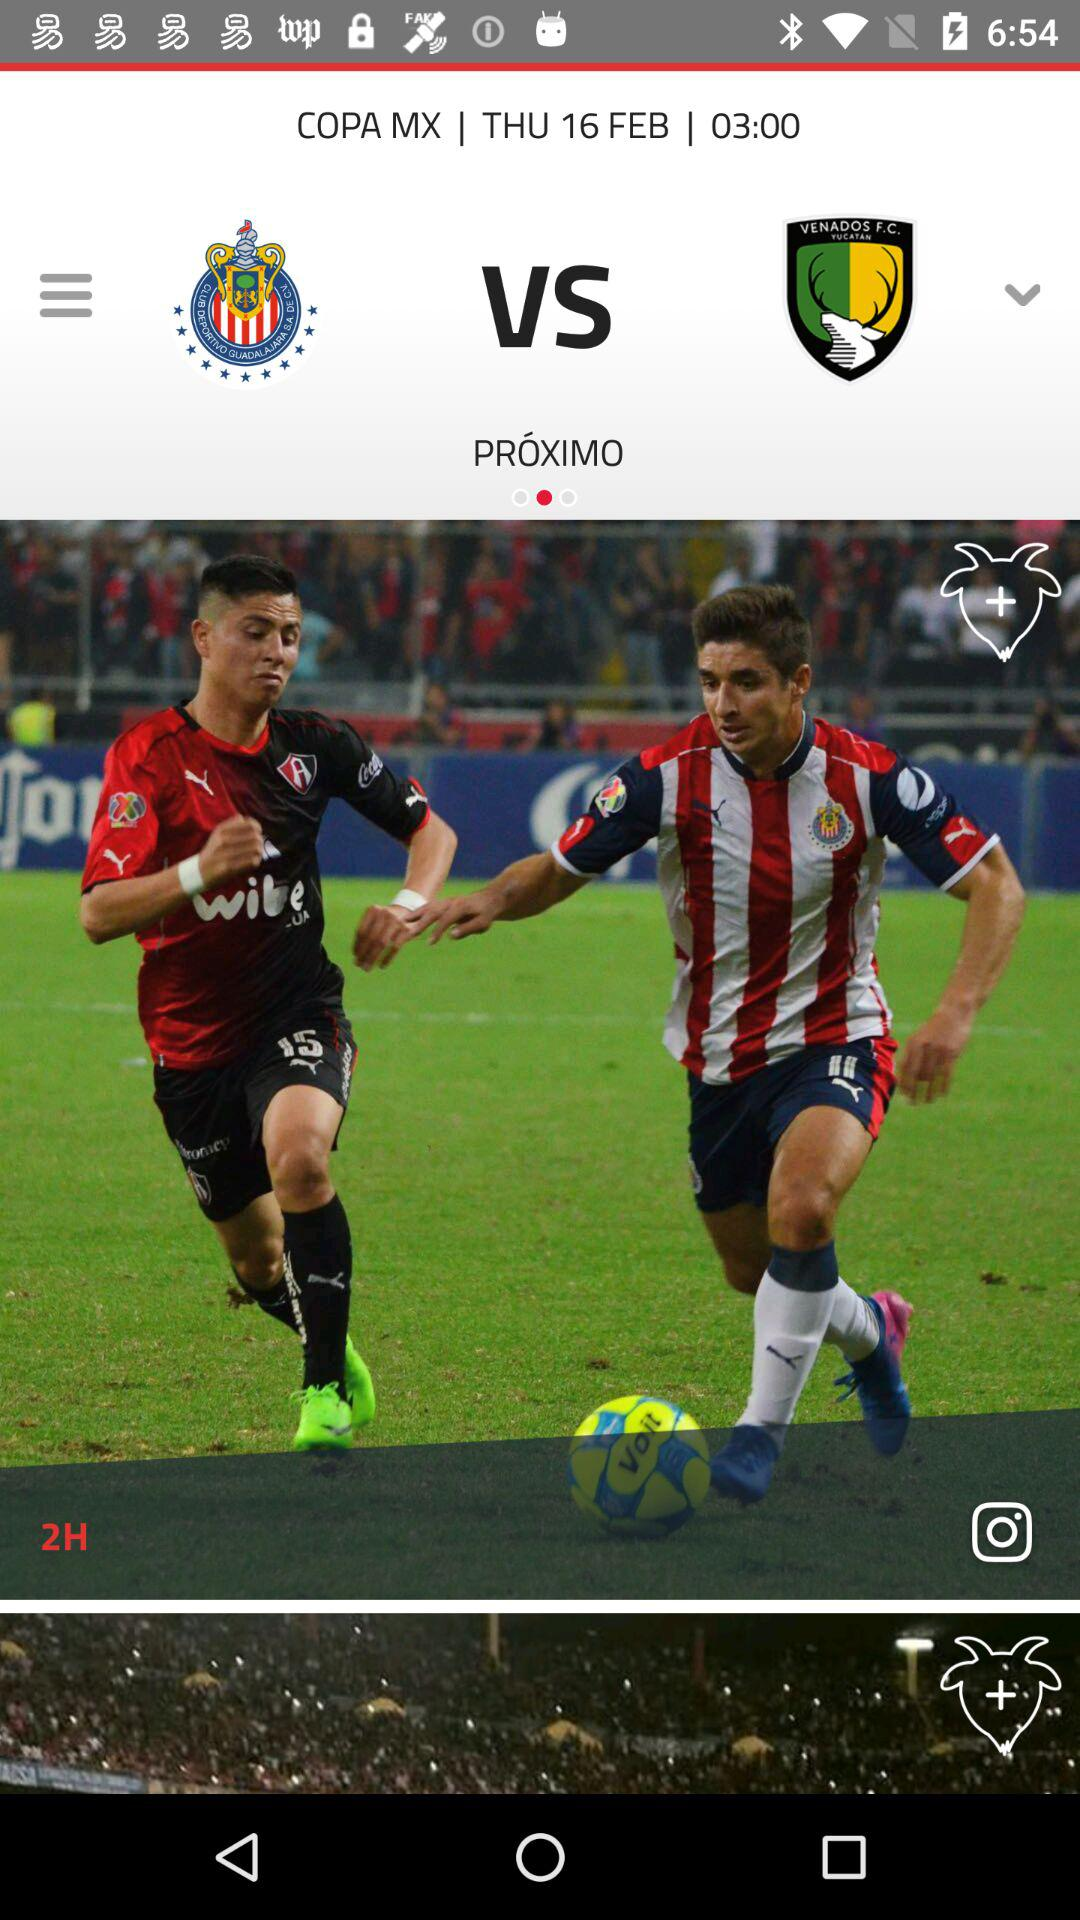What else can be inferred about the match from the image? Aside from the main action, one can infer that the match is part of a tournament called 'COPA MX' set on Thursday, 16 February, which suggests it is an important competitive event, possibly a cup match. 